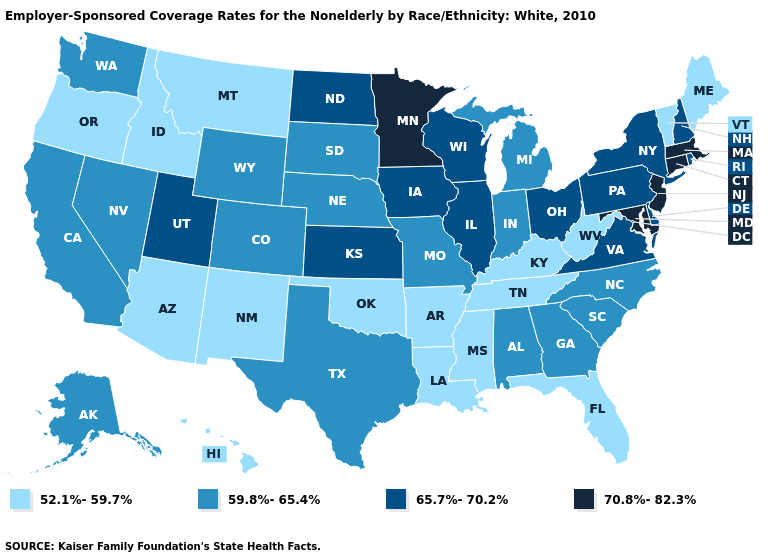What is the value of Oklahoma?
Give a very brief answer. 52.1%-59.7%. What is the value of Tennessee?
Concise answer only. 52.1%-59.7%. What is the value of Massachusetts?
Write a very short answer. 70.8%-82.3%. Which states hav the highest value in the South?
Quick response, please. Maryland. Name the states that have a value in the range 65.7%-70.2%?
Quick response, please. Delaware, Illinois, Iowa, Kansas, New Hampshire, New York, North Dakota, Ohio, Pennsylvania, Rhode Island, Utah, Virginia, Wisconsin. Name the states that have a value in the range 65.7%-70.2%?
Quick response, please. Delaware, Illinois, Iowa, Kansas, New Hampshire, New York, North Dakota, Ohio, Pennsylvania, Rhode Island, Utah, Virginia, Wisconsin. What is the value of Texas?
Quick response, please. 59.8%-65.4%. Which states hav the highest value in the MidWest?
Write a very short answer. Minnesota. Is the legend a continuous bar?
Short answer required. No. How many symbols are there in the legend?
Concise answer only. 4. What is the lowest value in states that border Nebraska?
Give a very brief answer. 59.8%-65.4%. What is the value of Indiana?
Write a very short answer. 59.8%-65.4%. What is the value of California?
Keep it brief. 59.8%-65.4%. What is the value of Delaware?
Keep it brief. 65.7%-70.2%. 